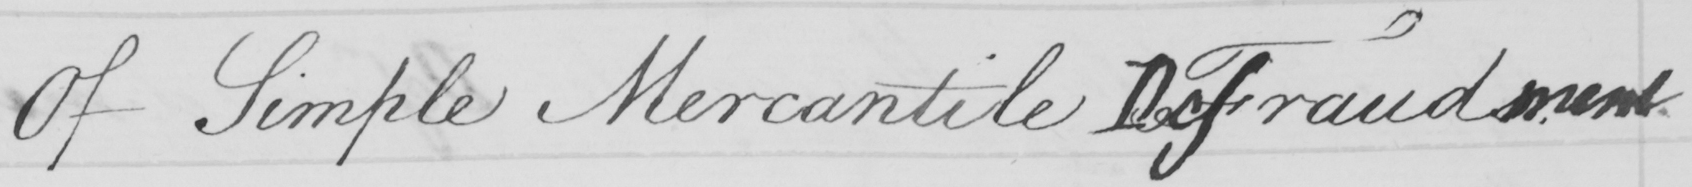Please provide the text content of this handwritten line. Of Simple Mercantile FDefrauds.ment . 